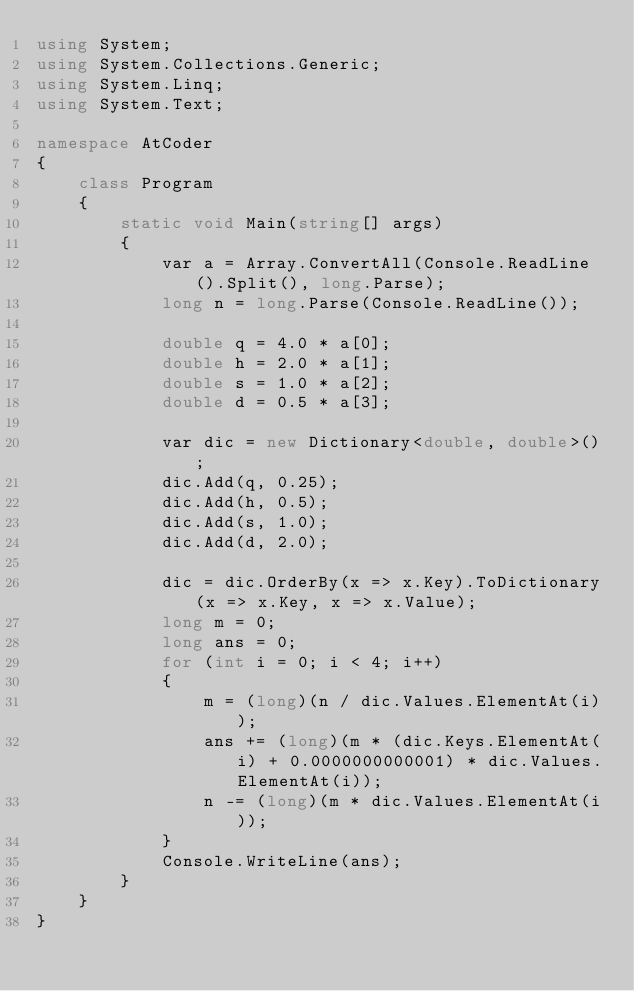<code> <loc_0><loc_0><loc_500><loc_500><_C#_>using System;
using System.Collections.Generic;
using System.Linq;
using System.Text;

namespace AtCoder
{
    class Program
    {
        static void Main(string[] args)
        {
            var a = Array.ConvertAll(Console.ReadLine().Split(), long.Parse);
            long n = long.Parse(Console.ReadLine());

            double q = 4.0 * a[0];
            double h = 2.0 * a[1];
            double s = 1.0 * a[2];
            double d = 0.5 * a[3];

            var dic = new Dictionary<double, double>();
            dic.Add(q, 0.25);
            dic.Add(h, 0.5);
            dic.Add(s, 1.0);
            dic.Add(d, 2.0);

            dic = dic.OrderBy(x => x.Key).ToDictionary(x => x.Key, x => x.Value);
            long m = 0;
            long ans = 0;
            for (int i = 0; i < 4; i++)
            {
                m = (long)(n / dic.Values.ElementAt(i));
                ans += (long)(m * (dic.Keys.ElementAt(i) + 0.0000000000001) * dic.Values.ElementAt(i));
                n -= (long)(m * dic.Values.ElementAt(i));
            }
            Console.WriteLine(ans);
        }
    }
}</code> 